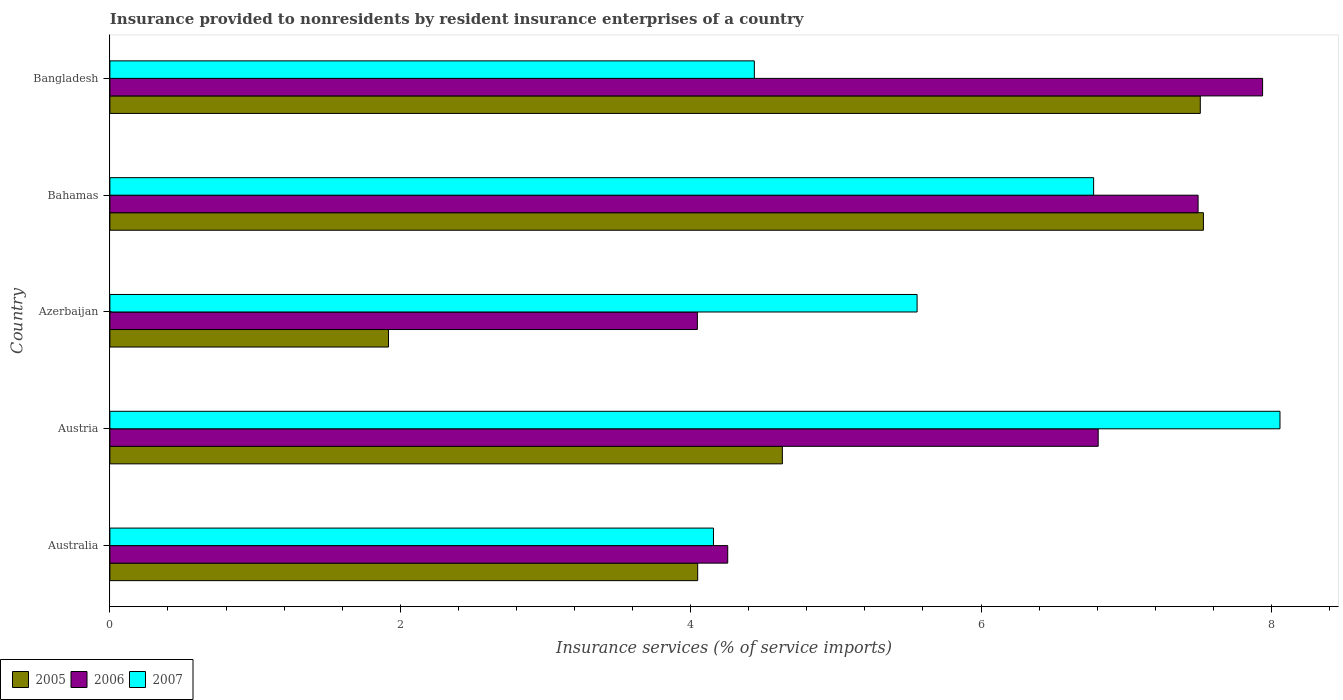How many different coloured bars are there?
Provide a succinct answer. 3. Are the number of bars per tick equal to the number of legend labels?
Provide a succinct answer. Yes. Are the number of bars on each tick of the Y-axis equal?
Provide a succinct answer. Yes. How many bars are there on the 1st tick from the bottom?
Keep it short and to the point. 3. What is the insurance provided to nonresidents in 2007 in Azerbaijan?
Your answer should be compact. 5.56. Across all countries, what is the maximum insurance provided to nonresidents in 2007?
Your answer should be compact. 8.06. Across all countries, what is the minimum insurance provided to nonresidents in 2005?
Provide a short and direct response. 1.92. In which country was the insurance provided to nonresidents in 2005 minimum?
Offer a terse response. Azerbaijan. What is the total insurance provided to nonresidents in 2006 in the graph?
Offer a terse response. 30.54. What is the difference between the insurance provided to nonresidents in 2005 in Austria and that in Bangladesh?
Give a very brief answer. -2.88. What is the difference between the insurance provided to nonresidents in 2005 in Azerbaijan and the insurance provided to nonresidents in 2007 in Austria?
Your answer should be very brief. -6.14. What is the average insurance provided to nonresidents in 2006 per country?
Offer a terse response. 6.11. What is the difference between the insurance provided to nonresidents in 2006 and insurance provided to nonresidents in 2007 in Australia?
Ensure brevity in your answer.  0.1. In how many countries, is the insurance provided to nonresidents in 2005 greater than 6.4 %?
Provide a short and direct response. 2. What is the ratio of the insurance provided to nonresidents in 2006 in Austria to that in Azerbaijan?
Offer a very short reply. 1.68. Is the insurance provided to nonresidents in 2006 in Austria less than that in Bangladesh?
Your response must be concise. Yes. Is the difference between the insurance provided to nonresidents in 2006 in Australia and Austria greater than the difference between the insurance provided to nonresidents in 2007 in Australia and Austria?
Offer a terse response. Yes. What is the difference between the highest and the second highest insurance provided to nonresidents in 2006?
Offer a very short reply. 0.44. What is the difference between the highest and the lowest insurance provided to nonresidents in 2007?
Offer a terse response. 3.9. In how many countries, is the insurance provided to nonresidents in 2006 greater than the average insurance provided to nonresidents in 2006 taken over all countries?
Offer a terse response. 3. Is the sum of the insurance provided to nonresidents in 2005 in Austria and Bahamas greater than the maximum insurance provided to nonresidents in 2006 across all countries?
Offer a terse response. Yes. What does the 3rd bar from the top in Bangladesh represents?
Your response must be concise. 2005. What does the 3rd bar from the bottom in Bangladesh represents?
Keep it short and to the point. 2007. Is it the case that in every country, the sum of the insurance provided to nonresidents in 2007 and insurance provided to nonresidents in 2006 is greater than the insurance provided to nonresidents in 2005?
Your answer should be compact. Yes. How many countries are there in the graph?
Offer a terse response. 5. What is the difference between two consecutive major ticks on the X-axis?
Provide a succinct answer. 2. Are the values on the major ticks of X-axis written in scientific E-notation?
Offer a very short reply. No. Does the graph contain any zero values?
Ensure brevity in your answer.  No. Does the graph contain grids?
Keep it short and to the point. No. How many legend labels are there?
Keep it short and to the point. 3. How are the legend labels stacked?
Your response must be concise. Horizontal. What is the title of the graph?
Offer a very short reply. Insurance provided to nonresidents by resident insurance enterprises of a country. What is the label or title of the X-axis?
Your answer should be compact. Insurance services (% of service imports). What is the Insurance services (% of service imports) of 2005 in Australia?
Ensure brevity in your answer.  4.05. What is the Insurance services (% of service imports) in 2006 in Australia?
Ensure brevity in your answer.  4.26. What is the Insurance services (% of service imports) in 2007 in Australia?
Offer a terse response. 4.16. What is the Insurance services (% of service imports) in 2005 in Austria?
Provide a short and direct response. 4.63. What is the Insurance services (% of service imports) in 2006 in Austria?
Your response must be concise. 6.81. What is the Insurance services (% of service imports) in 2007 in Austria?
Offer a terse response. 8.06. What is the Insurance services (% of service imports) of 2005 in Azerbaijan?
Keep it short and to the point. 1.92. What is the Insurance services (% of service imports) of 2006 in Azerbaijan?
Your answer should be compact. 4.05. What is the Insurance services (% of service imports) in 2007 in Azerbaijan?
Your answer should be very brief. 5.56. What is the Insurance services (% of service imports) of 2005 in Bahamas?
Your answer should be very brief. 7.53. What is the Insurance services (% of service imports) in 2006 in Bahamas?
Keep it short and to the point. 7.5. What is the Insurance services (% of service imports) of 2007 in Bahamas?
Ensure brevity in your answer.  6.78. What is the Insurance services (% of service imports) in 2005 in Bangladesh?
Ensure brevity in your answer.  7.51. What is the Insurance services (% of service imports) in 2006 in Bangladesh?
Keep it short and to the point. 7.94. What is the Insurance services (% of service imports) of 2007 in Bangladesh?
Keep it short and to the point. 4.44. Across all countries, what is the maximum Insurance services (% of service imports) in 2005?
Provide a short and direct response. 7.53. Across all countries, what is the maximum Insurance services (% of service imports) of 2006?
Make the answer very short. 7.94. Across all countries, what is the maximum Insurance services (% of service imports) of 2007?
Your answer should be very brief. 8.06. Across all countries, what is the minimum Insurance services (% of service imports) in 2005?
Your response must be concise. 1.92. Across all countries, what is the minimum Insurance services (% of service imports) of 2006?
Your response must be concise. 4.05. Across all countries, what is the minimum Insurance services (% of service imports) of 2007?
Give a very brief answer. 4.16. What is the total Insurance services (% of service imports) in 2005 in the graph?
Give a very brief answer. 25.64. What is the total Insurance services (% of service imports) of 2006 in the graph?
Your answer should be compact. 30.54. What is the total Insurance services (% of service imports) in 2007 in the graph?
Provide a short and direct response. 28.99. What is the difference between the Insurance services (% of service imports) of 2005 in Australia and that in Austria?
Your answer should be very brief. -0.58. What is the difference between the Insurance services (% of service imports) of 2006 in Australia and that in Austria?
Provide a succinct answer. -2.55. What is the difference between the Insurance services (% of service imports) of 2007 in Australia and that in Austria?
Give a very brief answer. -3.9. What is the difference between the Insurance services (% of service imports) in 2005 in Australia and that in Azerbaijan?
Offer a terse response. 2.13. What is the difference between the Insurance services (% of service imports) of 2006 in Australia and that in Azerbaijan?
Your response must be concise. 0.21. What is the difference between the Insurance services (% of service imports) of 2007 in Australia and that in Azerbaijan?
Your response must be concise. -1.4. What is the difference between the Insurance services (% of service imports) of 2005 in Australia and that in Bahamas?
Give a very brief answer. -3.48. What is the difference between the Insurance services (% of service imports) of 2006 in Australia and that in Bahamas?
Ensure brevity in your answer.  -3.24. What is the difference between the Insurance services (% of service imports) in 2007 in Australia and that in Bahamas?
Your response must be concise. -2.62. What is the difference between the Insurance services (% of service imports) of 2005 in Australia and that in Bangladesh?
Your answer should be compact. -3.46. What is the difference between the Insurance services (% of service imports) of 2006 in Australia and that in Bangladesh?
Offer a very short reply. -3.68. What is the difference between the Insurance services (% of service imports) in 2007 in Australia and that in Bangladesh?
Make the answer very short. -0.28. What is the difference between the Insurance services (% of service imports) in 2005 in Austria and that in Azerbaijan?
Your answer should be very brief. 2.71. What is the difference between the Insurance services (% of service imports) of 2006 in Austria and that in Azerbaijan?
Your answer should be compact. 2.76. What is the difference between the Insurance services (% of service imports) of 2007 in Austria and that in Azerbaijan?
Your answer should be compact. 2.5. What is the difference between the Insurance services (% of service imports) in 2005 in Austria and that in Bahamas?
Your response must be concise. -2.9. What is the difference between the Insurance services (% of service imports) of 2006 in Austria and that in Bahamas?
Ensure brevity in your answer.  -0.69. What is the difference between the Insurance services (% of service imports) in 2007 in Austria and that in Bahamas?
Ensure brevity in your answer.  1.28. What is the difference between the Insurance services (% of service imports) in 2005 in Austria and that in Bangladesh?
Make the answer very short. -2.88. What is the difference between the Insurance services (% of service imports) in 2006 in Austria and that in Bangladesh?
Keep it short and to the point. -1.13. What is the difference between the Insurance services (% of service imports) of 2007 in Austria and that in Bangladesh?
Give a very brief answer. 3.62. What is the difference between the Insurance services (% of service imports) in 2005 in Azerbaijan and that in Bahamas?
Offer a very short reply. -5.61. What is the difference between the Insurance services (% of service imports) in 2006 in Azerbaijan and that in Bahamas?
Ensure brevity in your answer.  -3.45. What is the difference between the Insurance services (% of service imports) of 2007 in Azerbaijan and that in Bahamas?
Keep it short and to the point. -1.22. What is the difference between the Insurance services (% of service imports) of 2005 in Azerbaijan and that in Bangladesh?
Give a very brief answer. -5.59. What is the difference between the Insurance services (% of service imports) of 2006 in Azerbaijan and that in Bangladesh?
Make the answer very short. -3.89. What is the difference between the Insurance services (% of service imports) in 2007 in Azerbaijan and that in Bangladesh?
Give a very brief answer. 1.12. What is the difference between the Insurance services (% of service imports) in 2005 in Bahamas and that in Bangladesh?
Give a very brief answer. 0.02. What is the difference between the Insurance services (% of service imports) in 2006 in Bahamas and that in Bangladesh?
Give a very brief answer. -0.44. What is the difference between the Insurance services (% of service imports) of 2007 in Bahamas and that in Bangladesh?
Your response must be concise. 2.34. What is the difference between the Insurance services (% of service imports) in 2005 in Australia and the Insurance services (% of service imports) in 2006 in Austria?
Offer a terse response. -2.76. What is the difference between the Insurance services (% of service imports) of 2005 in Australia and the Insurance services (% of service imports) of 2007 in Austria?
Provide a short and direct response. -4.01. What is the difference between the Insurance services (% of service imports) in 2006 in Australia and the Insurance services (% of service imports) in 2007 in Austria?
Your answer should be very brief. -3.8. What is the difference between the Insurance services (% of service imports) in 2005 in Australia and the Insurance services (% of service imports) in 2006 in Azerbaijan?
Your answer should be very brief. 0. What is the difference between the Insurance services (% of service imports) of 2005 in Australia and the Insurance services (% of service imports) of 2007 in Azerbaijan?
Offer a very short reply. -1.51. What is the difference between the Insurance services (% of service imports) of 2006 in Australia and the Insurance services (% of service imports) of 2007 in Azerbaijan?
Your answer should be compact. -1.3. What is the difference between the Insurance services (% of service imports) of 2005 in Australia and the Insurance services (% of service imports) of 2006 in Bahamas?
Your response must be concise. -3.45. What is the difference between the Insurance services (% of service imports) in 2005 in Australia and the Insurance services (% of service imports) in 2007 in Bahamas?
Keep it short and to the point. -2.73. What is the difference between the Insurance services (% of service imports) in 2006 in Australia and the Insurance services (% of service imports) in 2007 in Bahamas?
Offer a very short reply. -2.52. What is the difference between the Insurance services (% of service imports) of 2005 in Australia and the Insurance services (% of service imports) of 2006 in Bangladesh?
Give a very brief answer. -3.89. What is the difference between the Insurance services (% of service imports) of 2005 in Australia and the Insurance services (% of service imports) of 2007 in Bangladesh?
Make the answer very short. -0.39. What is the difference between the Insurance services (% of service imports) of 2006 in Australia and the Insurance services (% of service imports) of 2007 in Bangladesh?
Make the answer very short. -0.18. What is the difference between the Insurance services (% of service imports) of 2005 in Austria and the Insurance services (% of service imports) of 2006 in Azerbaijan?
Offer a terse response. 0.59. What is the difference between the Insurance services (% of service imports) of 2005 in Austria and the Insurance services (% of service imports) of 2007 in Azerbaijan?
Your answer should be very brief. -0.93. What is the difference between the Insurance services (% of service imports) of 2006 in Austria and the Insurance services (% of service imports) of 2007 in Azerbaijan?
Offer a terse response. 1.25. What is the difference between the Insurance services (% of service imports) in 2005 in Austria and the Insurance services (% of service imports) in 2006 in Bahamas?
Give a very brief answer. -2.86. What is the difference between the Insurance services (% of service imports) of 2005 in Austria and the Insurance services (% of service imports) of 2007 in Bahamas?
Provide a succinct answer. -2.14. What is the difference between the Insurance services (% of service imports) of 2006 in Austria and the Insurance services (% of service imports) of 2007 in Bahamas?
Provide a succinct answer. 0.03. What is the difference between the Insurance services (% of service imports) of 2005 in Austria and the Insurance services (% of service imports) of 2006 in Bangladesh?
Your answer should be very brief. -3.31. What is the difference between the Insurance services (% of service imports) of 2005 in Austria and the Insurance services (% of service imports) of 2007 in Bangladesh?
Keep it short and to the point. 0.19. What is the difference between the Insurance services (% of service imports) of 2006 in Austria and the Insurance services (% of service imports) of 2007 in Bangladesh?
Provide a short and direct response. 2.37. What is the difference between the Insurance services (% of service imports) in 2005 in Azerbaijan and the Insurance services (% of service imports) in 2006 in Bahamas?
Give a very brief answer. -5.58. What is the difference between the Insurance services (% of service imports) in 2005 in Azerbaijan and the Insurance services (% of service imports) in 2007 in Bahamas?
Your answer should be compact. -4.86. What is the difference between the Insurance services (% of service imports) in 2006 in Azerbaijan and the Insurance services (% of service imports) in 2007 in Bahamas?
Your answer should be compact. -2.73. What is the difference between the Insurance services (% of service imports) in 2005 in Azerbaijan and the Insurance services (% of service imports) in 2006 in Bangladesh?
Provide a succinct answer. -6.02. What is the difference between the Insurance services (% of service imports) of 2005 in Azerbaijan and the Insurance services (% of service imports) of 2007 in Bangladesh?
Keep it short and to the point. -2.52. What is the difference between the Insurance services (% of service imports) of 2006 in Azerbaijan and the Insurance services (% of service imports) of 2007 in Bangladesh?
Provide a short and direct response. -0.39. What is the difference between the Insurance services (% of service imports) in 2005 in Bahamas and the Insurance services (% of service imports) in 2006 in Bangladesh?
Your answer should be compact. -0.41. What is the difference between the Insurance services (% of service imports) in 2005 in Bahamas and the Insurance services (% of service imports) in 2007 in Bangladesh?
Offer a very short reply. 3.09. What is the difference between the Insurance services (% of service imports) in 2006 in Bahamas and the Insurance services (% of service imports) in 2007 in Bangladesh?
Keep it short and to the point. 3.06. What is the average Insurance services (% of service imports) in 2005 per country?
Offer a very short reply. 5.13. What is the average Insurance services (% of service imports) in 2006 per country?
Give a very brief answer. 6.11. What is the average Insurance services (% of service imports) in 2007 per country?
Your answer should be very brief. 5.8. What is the difference between the Insurance services (% of service imports) in 2005 and Insurance services (% of service imports) in 2006 in Australia?
Provide a succinct answer. -0.21. What is the difference between the Insurance services (% of service imports) of 2005 and Insurance services (% of service imports) of 2007 in Australia?
Provide a short and direct response. -0.11. What is the difference between the Insurance services (% of service imports) of 2006 and Insurance services (% of service imports) of 2007 in Australia?
Ensure brevity in your answer.  0.1. What is the difference between the Insurance services (% of service imports) of 2005 and Insurance services (% of service imports) of 2006 in Austria?
Ensure brevity in your answer.  -2.18. What is the difference between the Insurance services (% of service imports) in 2005 and Insurance services (% of service imports) in 2007 in Austria?
Give a very brief answer. -3.43. What is the difference between the Insurance services (% of service imports) in 2006 and Insurance services (% of service imports) in 2007 in Austria?
Give a very brief answer. -1.25. What is the difference between the Insurance services (% of service imports) in 2005 and Insurance services (% of service imports) in 2006 in Azerbaijan?
Make the answer very short. -2.13. What is the difference between the Insurance services (% of service imports) in 2005 and Insurance services (% of service imports) in 2007 in Azerbaijan?
Provide a short and direct response. -3.64. What is the difference between the Insurance services (% of service imports) in 2006 and Insurance services (% of service imports) in 2007 in Azerbaijan?
Offer a terse response. -1.51. What is the difference between the Insurance services (% of service imports) in 2005 and Insurance services (% of service imports) in 2006 in Bahamas?
Ensure brevity in your answer.  0.04. What is the difference between the Insurance services (% of service imports) of 2005 and Insurance services (% of service imports) of 2007 in Bahamas?
Your response must be concise. 0.76. What is the difference between the Insurance services (% of service imports) in 2006 and Insurance services (% of service imports) in 2007 in Bahamas?
Make the answer very short. 0.72. What is the difference between the Insurance services (% of service imports) in 2005 and Insurance services (% of service imports) in 2006 in Bangladesh?
Offer a very short reply. -0.43. What is the difference between the Insurance services (% of service imports) in 2005 and Insurance services (% of service imports) in 2007 in Bangladesh?
Provide a succinct answer. 3.07. What is the difference between the Insurance services (% of service imports) of 2006 and Insurance services (% of service imports) of 2007 in Bangladesh?
Ensure brevity in your answer.  3.5. What is the ratio of the Insurance services (% of service imports) in 2005 in Australia to that in Austria?
Your answer should be compact. 0.87. What is the ratio of the Insurance services (% of service imports) of 2006 in Australia to that in Austria?
Offer a terse response. 0.63. What is the ratio of the Insurance services (% of service imports) in 2007 in Australia to that in Austria?
Offer a very short reply. 0.52. What is the ratio of the Insurance services (% of service imports) of 2005 in Australia to that in Azerbaijan?
Offer a very short reply. 2.11. What is the ratio of the Insurance services (% of service imports) in 2006 in Australia to that in Azerbaijan?
Your response must be concise. 1.05. What is the ratio of the Insurance services (% of service imports) of 2007 in Australia to that in Azerbaijan?
Keep it short and to the point. 0.75. What is the ratio of the Insurance services (% of service imports) of 2005 in Australia to that in Bahamas?
Offer a very short reply. 0.54. What is the ratio of the Insurance services (% of service imports) in 2006 in Australia to that in Bahamas?
Offer a very short reply. 0.57. What is the ratio of the Insurance services (% of service imports) of 2007 in Australia to that in Bahamas?
Your response must be concise. 0.61. What is the ratio of the Insurance services (% of service imports) in 2005 in Australia to that in Bangladesh?
Your response must be concise. 0.54. What is the ratio of the Insurance services (% of service imports) in 2006 in Australia to that in Bangladesh?
Provide a short and direct response. 0.54. What is the ratio of the Insurance services (% of service imports) in 2007 in Australia to that in Bangladesh?
Your answer should be compact. 0.94. What is the ratio of the Insurance services (% of service imports) of 2005 in Austria to that in Azerbaijan?
Your answer should be very brief. 2.41. What is the ratio of the Insurance services (% of service imports) of 2006 in Austria to that in Azerbaijan?
Give a very brief answer. 1.68. What is the ratio of the Insurance services (% of service imports) of 2007 in Austria to that in Azerbaijan?
Offer a very short reply. 1.45. What is the ratio of the Insurance services (% of service imports) of 2005 in Austria to that in Bahamas?
Your answer should be compact. 0.61. What is the ratio of the Insurance services (% of service imports) in 2006 in Austria to that in Bahamas?
Your answer should be very brief. 0.91. What is the ratio of the Insurance services (% of service imports) in 2007 in Austria to that in Bahamas?
Offer a terse response. 1.19. What is the ratio of the Insurance services (% of service imports) of 2005 in Austria to that in Bangladesh?
Offer a terse response. 0.62. What is the ratio of the Insurance services (% of service imports) of 2006 in Austria to that in Bangladesh?
Your answer should be very brief. 0.86. What is the ratio of the Insurance services (% of service imports) in 2007 in Austria to that in Bangladesh?
Provide a short and direct response. 1.82. What is the ratio of the Insurance services (% of service imports) of 2005 in Azerbaijan to that in Bahamas?
Make the answer very short. 0.25. What is the ratio of the Insurance services (% of service imports) in 2006 in Azerbaijan to that in Bahamas?
Provide a short and direct response. 0.54. What is the ratio of the Insurance services (% of service imports) of 2007 in Azerbaijan to that in Bahamas?
Offer a terse response. 0.82. What is the ratio of the Insurance services (% of service imports) in 2005 in Azerbaijan to that in Bangladesh?
Ensure brevity in your answer.  0.26. What is the ratio of the Insurance services (% of service imports) of 2006 in Azerbaijan to that in Bangladesh?
Offer a very short reply. 0.51. What is the ratio of the Insurance services (% of service imports) in 2007 in Azerbaijan to that in Bangladesh?
Provide a succinct answer. 1.25. What is the ratio of the Insurance services (% of service imports) of 2005 in Bahamas to that in Bangladesh?
Give a very brief answer. 1. What is the ratio of the Insurance services (% of service imports) of 2006 in Bahamas to that in Bangladesh?
Ensure brevity in your answer.  0.94. What is the ratio of the Insurance services (% of service imports) in 2007 in Bahamas to that in Bangladesh?
Make the answer very short. 1.53. What is the difference between the highest and the second highest Insurance services (% of service imports) of 2005?
Ensure brevity in your answer.  0.02. What is the difference between the highest and the second highest Insurance services (% of service imports) of 2006?
Give a very brief answer. 0.44. What is the difference between the highest and the second highest Insurance services (% of service imports) of 2007?
Your answer should be compact. 1.28. What is the difference between the highest and the lowest Insurance services (% of service imports) of 2005?
Offer a very short reply. 5.61. What is the difference between the highest and the lowest Insurance services (% of service imports) of 2006?
Provide a succinct answer. 3.89. What is the difference between the highest and the lowest Insurance services (% of service imports) of 2007?
Your answer should be very brief. 3.9. 